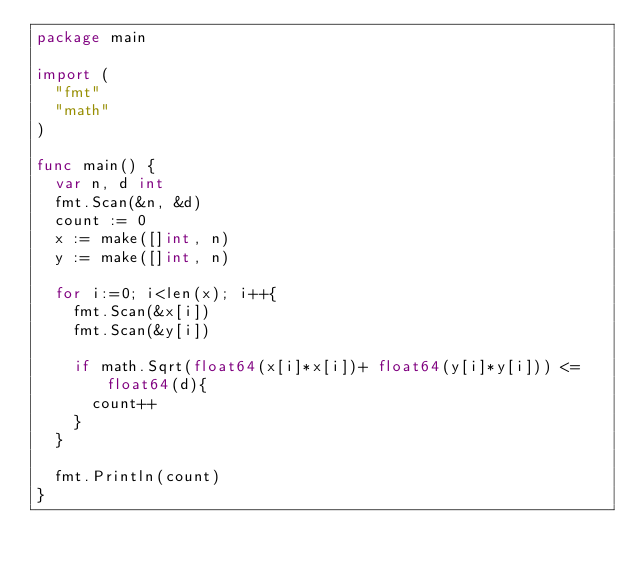Convert code to text. <code><loc_0><loc_0><loc_500><loc_500><_Go_>package main

import (
	"fmt"
	"math"
)

func main() {
	var n, d int
	fmt.Scan(&n, &d)
	count := 0
	x := make([]int, n)
	y := make([]int, n)

	for i:=0; i<len(x); i++{
		fmt.Scan(&x[i])
		fmt.Scan(&y[i])

		if math.Sqrt(float64(x[i]*x[i])+ float64(y[i]*y[i])) <= float64(d){
			count++
		}
	}

	fmt.Println(count)
}</code> 